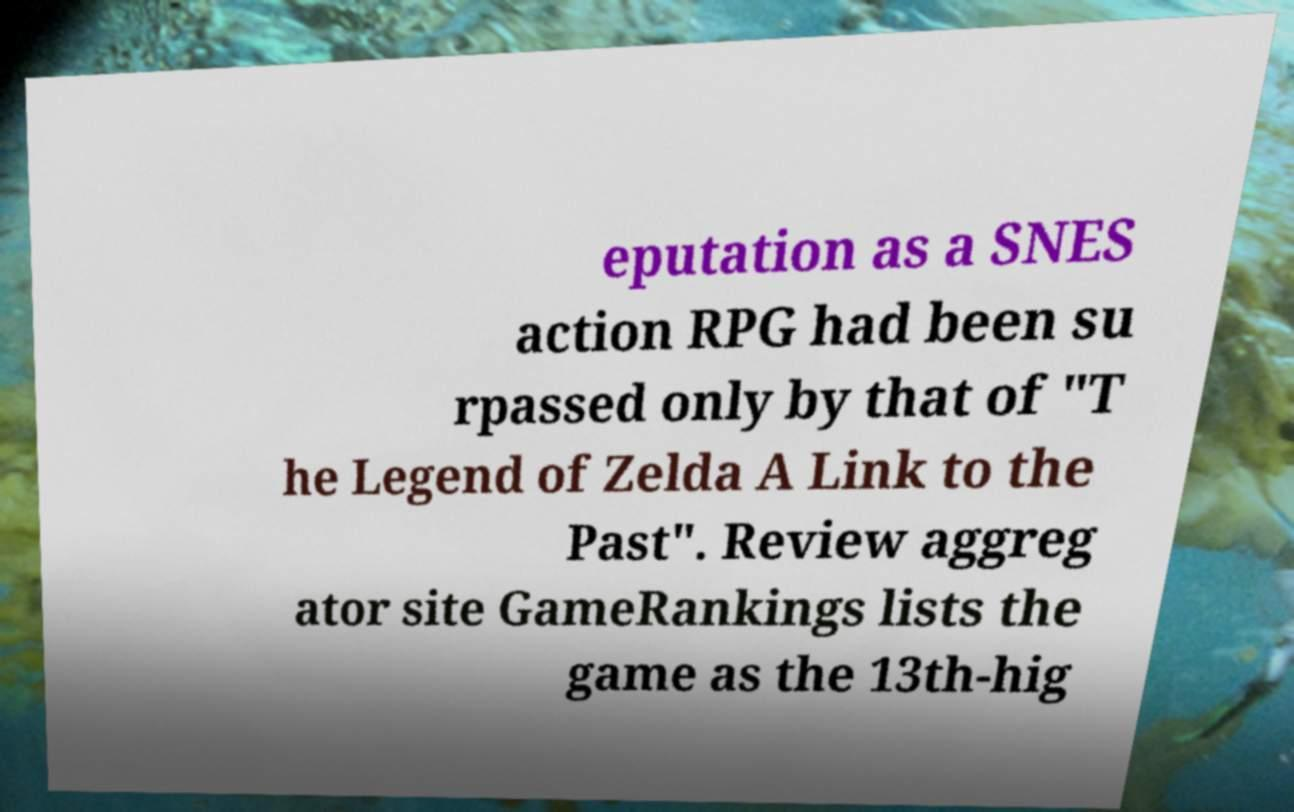Please identify and transcribe the text found in this image. eputation as a SNES action RPG had been su rpassed only by that of "T he Legend of Zelda A Link to the Past". Review aggreg ator site GameRankings lists the game as the 13th-hig 